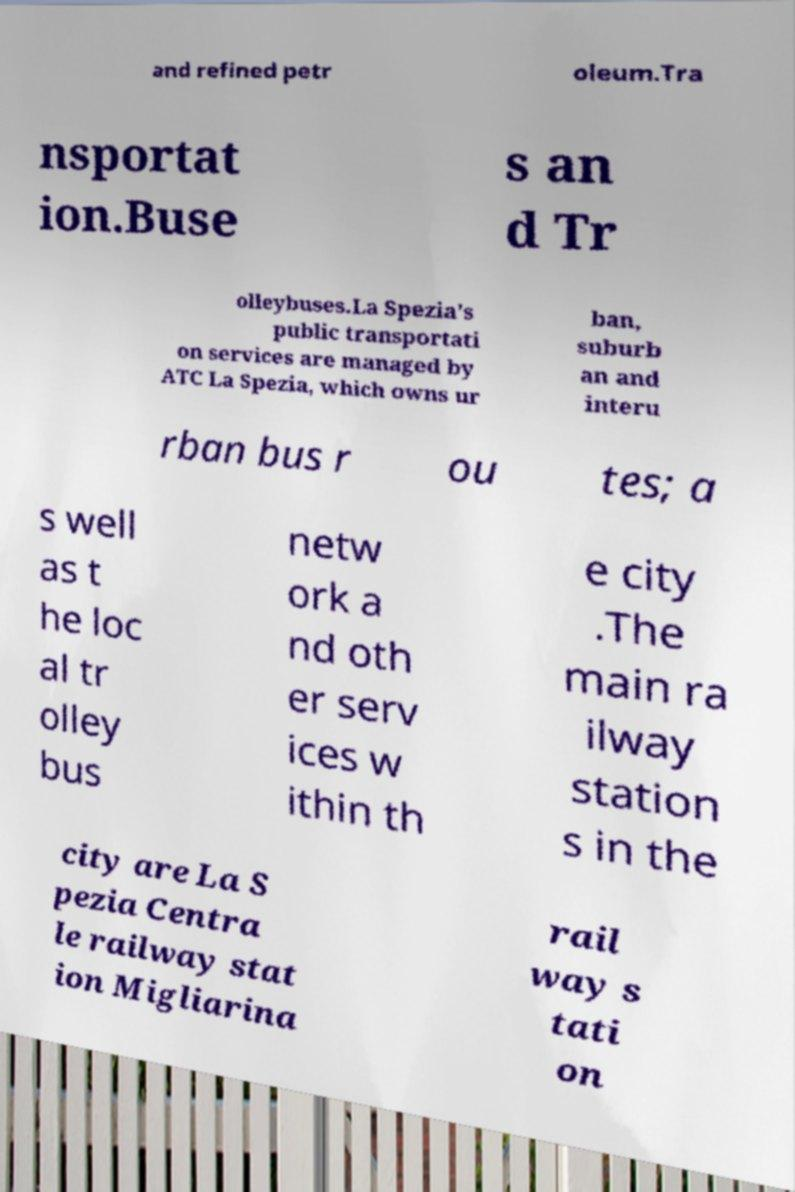Please identify and transcribe the text found in this image. and refined petr oleum.Tra nsportat ion.Buse s an d Tr olleybuses.La Spezia's public transportati on services are managed by ATC La Spezia, which owns ur ban, suburb an and interu rban bus r ou tes; a s well as t he loc al tr olley bus netw ork a nd oth er serv ices w ithin th e city .The main ra ilway station s in the city are La S pezia Centra le railway stat ion Migliarina rail way s tati on 